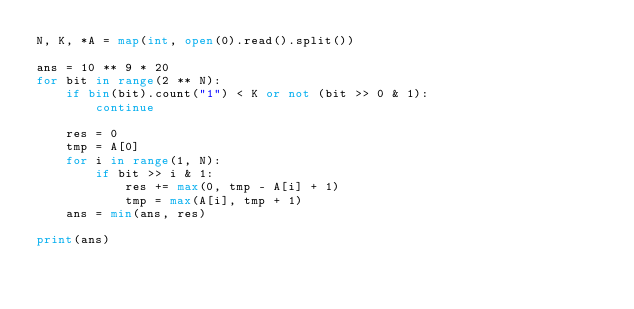Convert code to text. <code><loc_0><loc_0><loc_500><loc_500><_Python_>N, K, *A = map(int, open(0).read().split())

ans = 10 ** 9 * 20
for bit in range(2 ** N):
    if bin(bit).count("1") < K or not (bit >> 0 & 1):
        continue

    res = 0
    tmp = A[0]
    for i in range(1, N):
        if bit >> i & 1:
            res += max(0, tmp - A[i] + 1)
            tmp = max(A[i], tmp + 1)    
    ans = min(ans, res)

print(ans)
</code> 